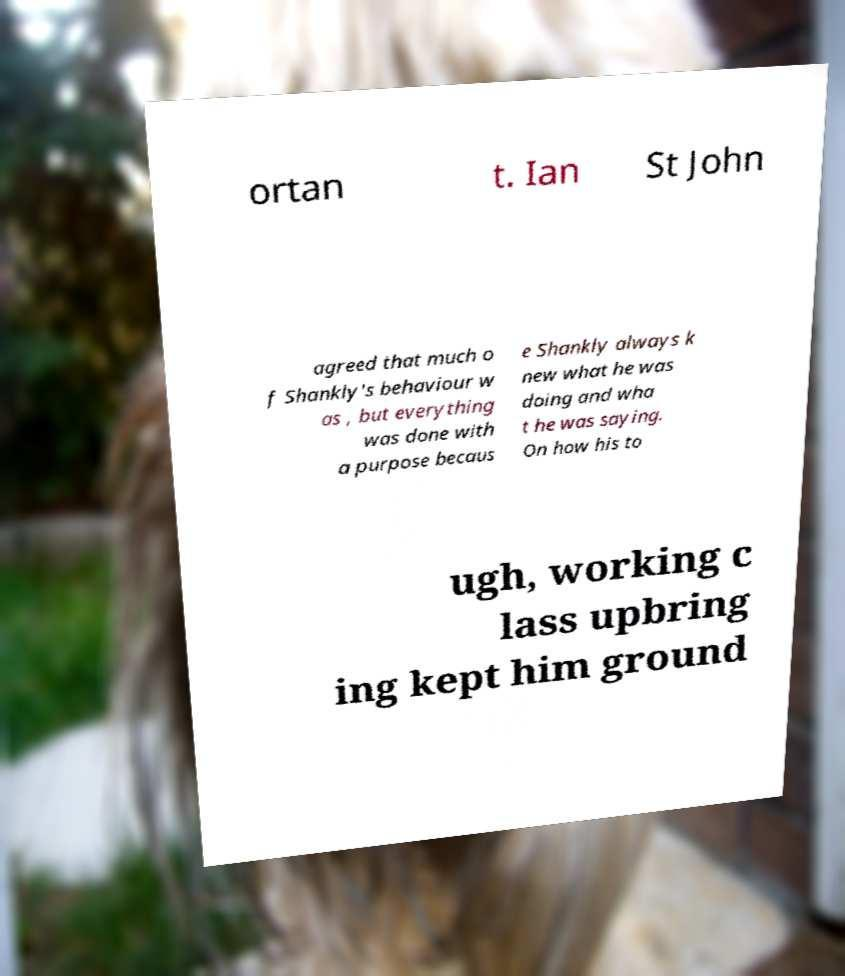There's text embedded in this image that I need extracted. Can you transcribe it verbatim? ortan t. Ian St John agreed that much o f Shankly's behaviour w as , but everything was done with a purpose becaus e Shankly always k new what he was doing and wha t he was saying. On how his to ugh, working c lass upbring ing kept him ground 